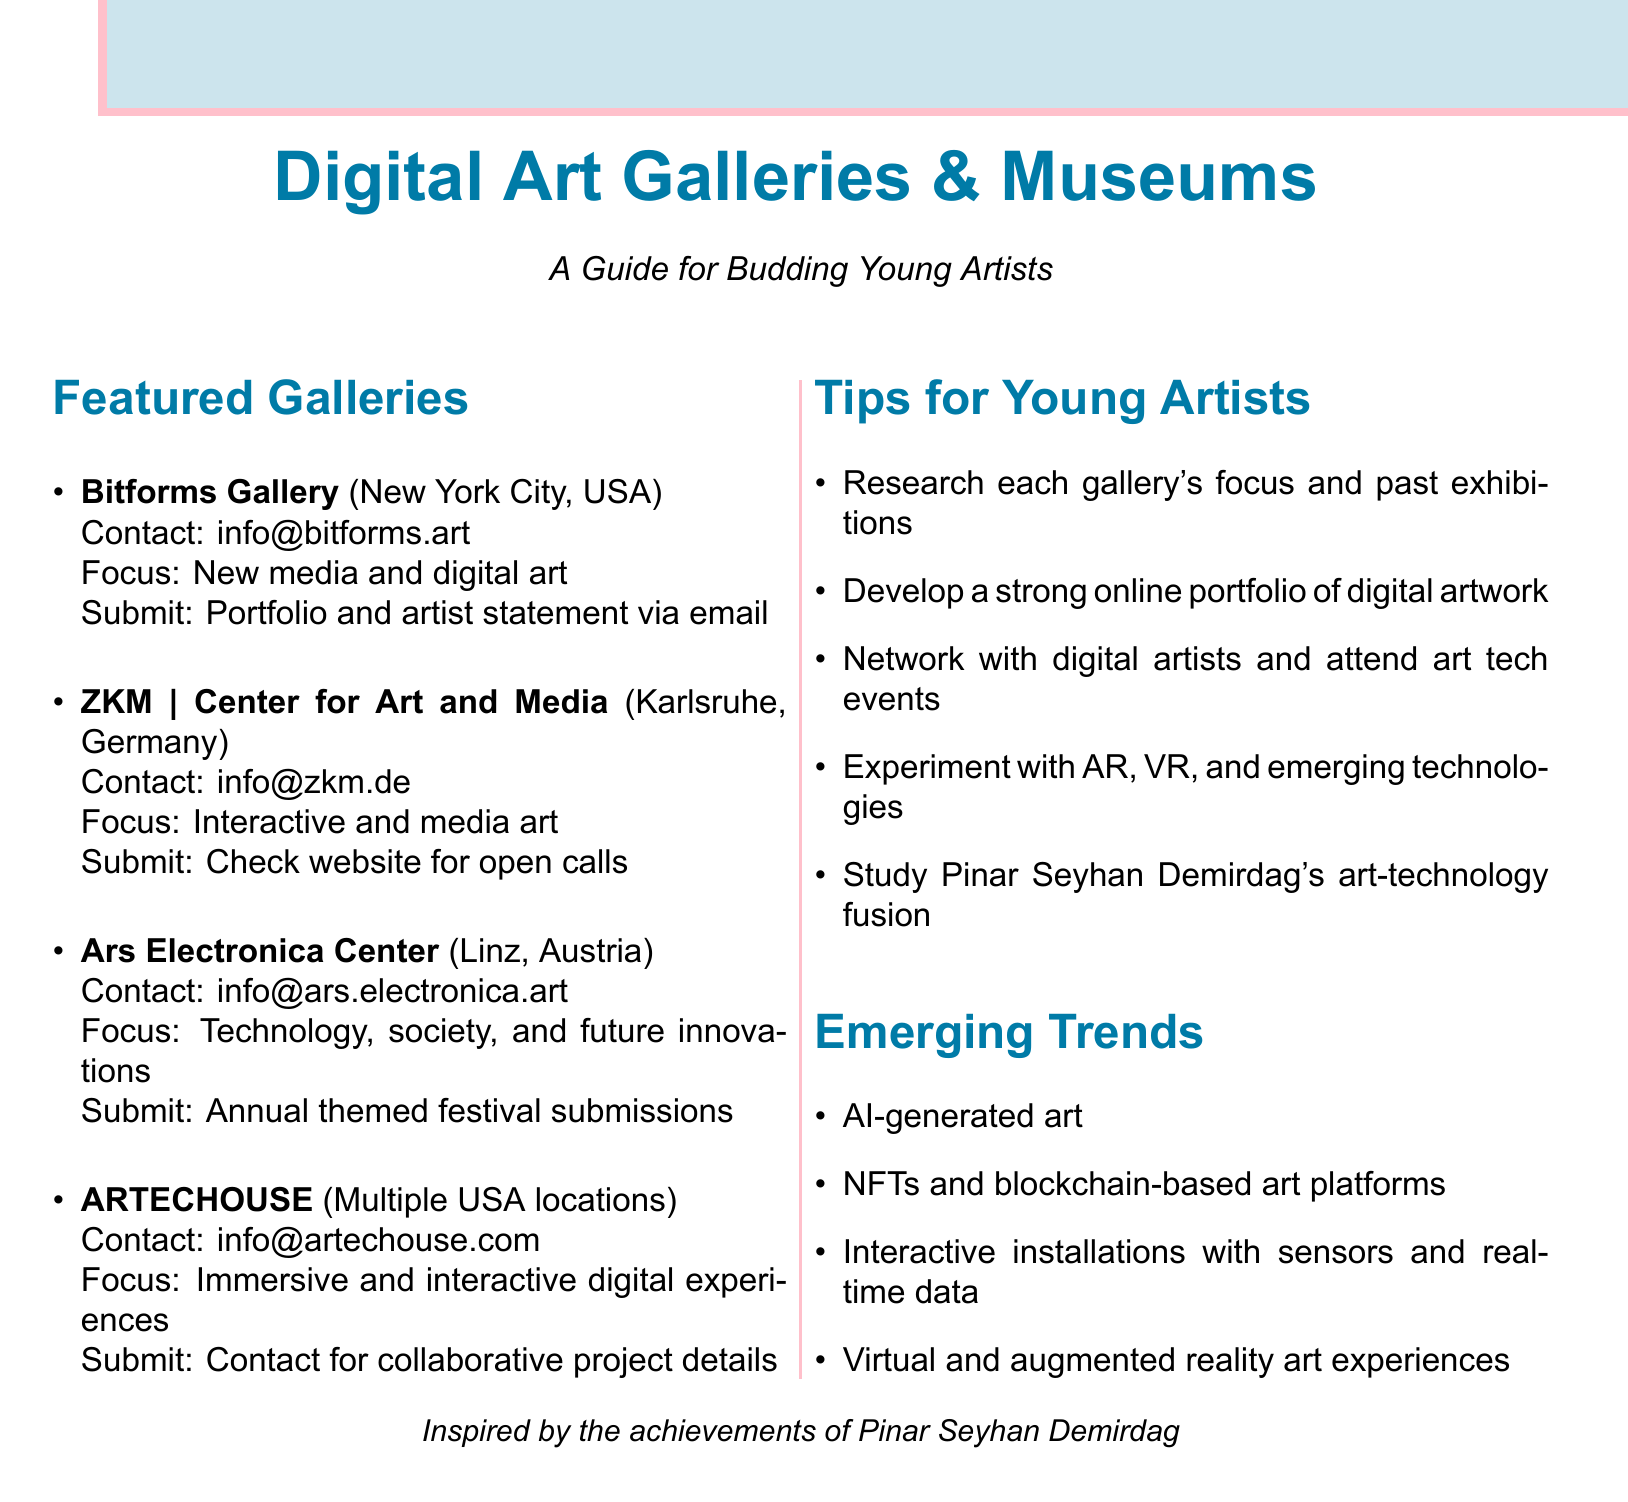What is the focus of Bitforms Gallery? The focus of Bitforms Gallery is specifically stated in the document as "New media and digital art."
Answer: New media and digital art Where is ZKM located? The location of ZKM is mentioned in the document as Karlsruhe, Germany.
Answer: Karlsruhe, Germany What type of art does the Ars Electronica Center emphasize? The document specifies that the Ars Electronica Center focuses on "Technology, society, and future innovations."
Answer: Technology, society, and future innovations How often are open calls posted at ZKM? The document mentions that open calls at ZKM are posted "periodically" on their website.
Answer: Periodically What is a suggested action for young artists mentioned in the tips? The tips for young artists suggest "Develop a strong online portfolio showcasing your digital artwork."
Answer: Develop a strong online portfolio What is an example of an emerging trend in digital art? The document lists "AI-generated art" as one of the emerging trends.
Answer: AI-generated art What submission material is required by Bitforms Gallery? It is specified that they require a "portfolio and artist statement via email."
Answer: Portfolio and artist statement via email Which gallery focuses on immersive digital experiences? The focus on immersive experiences is indicated as being with "ARTECHOUSE" in the document.
Answer: ARTECHOUSE What technology does the last tip suggest experimenting with? The last tip in the document encourages artists to experiment with "emerging technologies like AR and VR."
Answer: Emerging technologies like AR and VR 